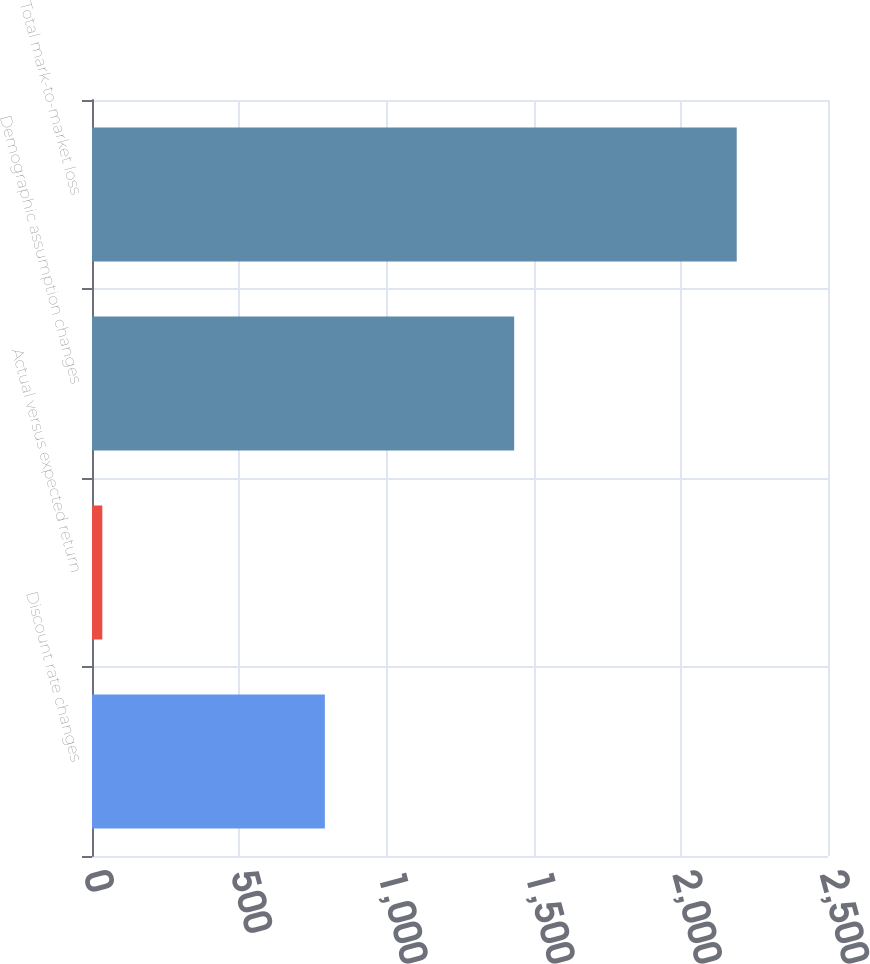<chart> <loc_0><loc_0><loc_500><loc_500><bar_chart><fcel>Discount rate changes<fcel>Actual versus expected return<fcel>Demographic assumption changes<fcel>Total mark-to-market loss<nl><fcel>791<fcel>35<fcel>1434<fcel>2190<nl></chart> 